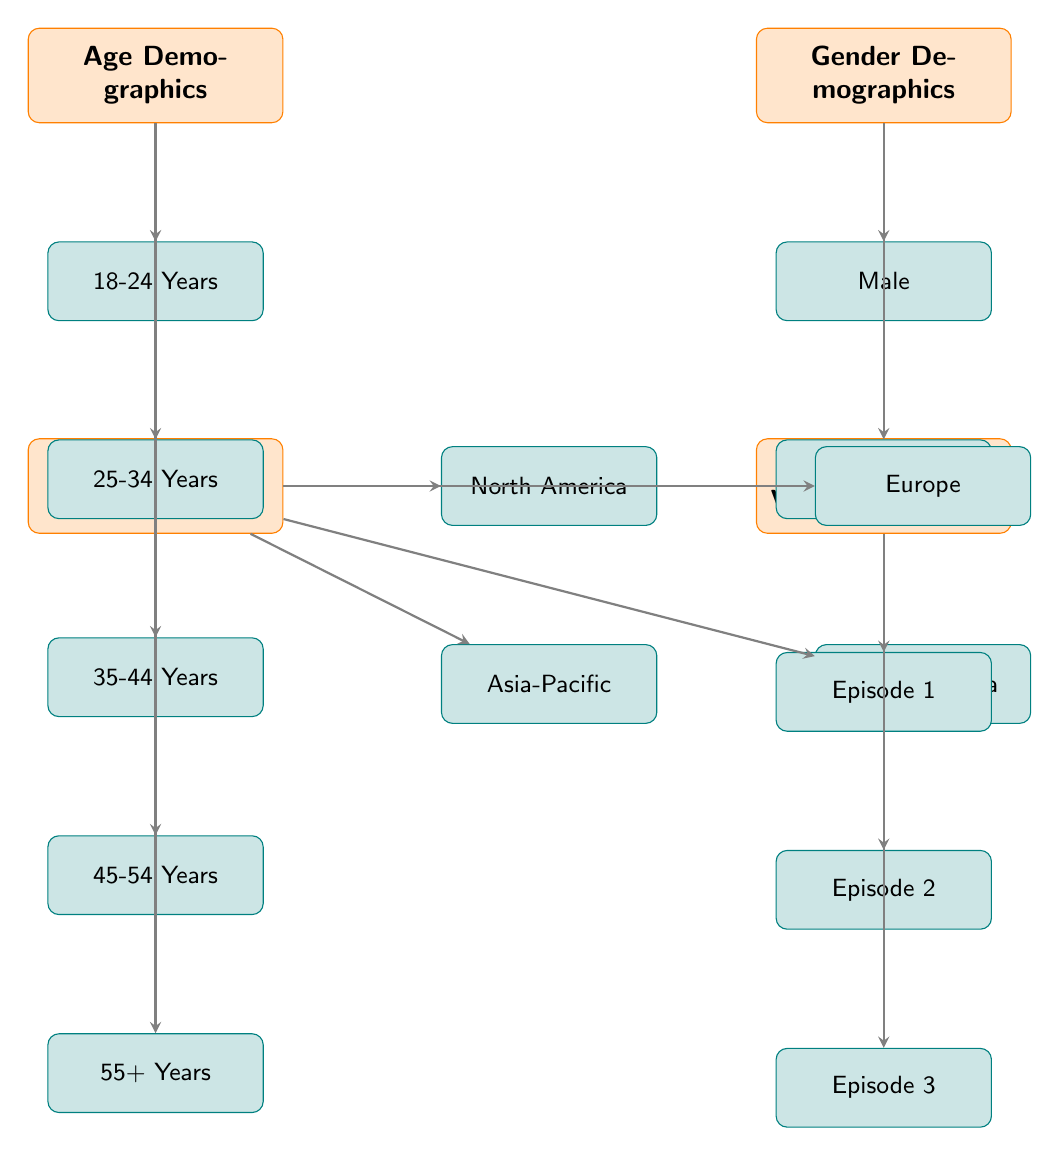What demographic age groups are represented in the diagram? The diagram presents five age groups: 18-24 Years, 25-34 Years, 35-44 Years, 45-54 Years, and 55+ Years, which are all listed under the Age Demographics category.
Answer: 18-24 Years, 25-34 Years, 35-44 Years, 45-54 Years, 55+ Years How many gender demographics are depicted in the diagram? There are two gender demographics shown: Male and Female, which are listed under the Gender Demographics category.
Answer: 2 Which geographic region comes first in the list? The first geographic region mentioned in the Geographic Region category is North America, as it is the first box that appears under this category.
Answer: North America What is the last episode listed in the comparative viewing statistics? The diagram lists three episodes under the Comparative Viewing Statistics category, with Episode 3 being the last in the sequence based on its position.
Answer: Episode 3 Which demographic category has more subcategories, age or gender? The Age Demographics category has five subcategories (age groups), while the Gender Demographics category has only two, making Age Demographics the category with more subcategories.
Answer: Age Demographics If we combine the age demographic 25-34 Years and the gender demographic Female, are they represented in the diagram? Both the age demographic 25-34 Years and the gender demographic Female are explicitly mentioned in their respective sections, indicating that they are represented.
Answer: Yes What relationship exists between the region Asia-Pacific and viewing statistics? The Asia-Pacific region does not directly connect to viewing statistics; it is only related through the Geographic Region category, which independently connects to the Comparative Viewing Statistics.
Answer: No direct connection Which demographic region is listed directly beneath Europe? Beneath Europe in the Geographic Region section is Latin America, since the arrangement of the regions follows a specific order in the diagram.
Answer: Latin America How many total categories are present in the diagram? The diagram includes four main categories: Age Demographics, Gender Demographics, Geographic Region, and Comparative Viewing Statistics, totaling four categories in all.
Answer: 4 